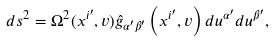<formula> <loc_0><loc_0><loc_500><loc_500>d s ^ { 2 } = \Omega ^ { 2 } ( x ^ { i ^ { \prime } } , v ) \hat { g } _ { \alpha ^ { \prime } \beta ^ { \prime } } \left ( x ^ { i ^ { \prime } } , v \right ) d u ^ { \alpha ^ { \prime } } d u ^ { \beta ^ { \prime } } ,</formula> 